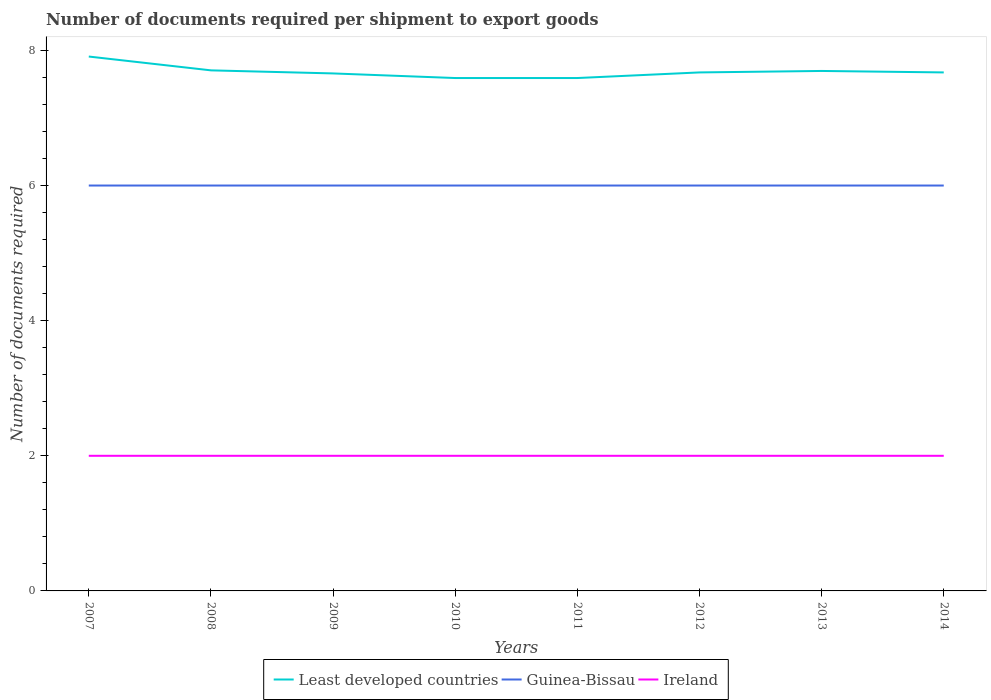How many different coloured lines are there?
Make the answer very short. 3. Does the line corresponding to Least developed countries intersect with the line corresponding to Ireland?
Ensure brevity in your answer.  No. Across all years, what is the maximum number of documents required per shipment to export goods in Least developed countries?
Provide a short and direct response. 7.59. What is the total number of documents required per shipment to export goods in Least developed countries in the graph?
Provide a succinct answer. 0.32. What is the difference between the highest and the lowest number of documents required per shipment to export goods in Least developed countries?
Provide a succinct answer. 3. How many years are there in the graph?
Offer a very short reply. 8. What is the difference between two consecutive major ticks on the Y-axis?
Your answer should be compact. 2. Where does the legend appear in the graph?
Your answer should be very brief. Bottom center. How many legend labels are there?
Provide a succinct answer. 3. How are the legend labels stacked?
Keep it short and to the point. Horizontal. What is the title of the graph?
Make the answer very short. Number of documents required per shipment to export goods. Does "Latin America(developing only)" appear as one of the legend labels in the graph?
Ensure brevity in your answer.  No. What is the label or title of the Y-axis?
Provide a short and direct response. Number of documents required. What is the Number of documents required of Least developed countries in 2007?
Offer a very short reply. 7.91. What is the Number of documents required of Guinea-Bissau in 2007?
Keep it short and to the point. 6. What is the Number of documents required of Least developed countries in 2008?
Your response must be concise. 7.7. What is the Number of documents required of Least developed countries in 2009?
Offer a terse response. 7.66. What is the Number of documents required of Guinea-Bissau in 2009?
Provide a short and direct response. 6. What is the Number of documents required in Least developed countries in 2010?
Make the answer very short. 7.59. What is the Number of documents required in Least developed countries in 2011?
Offer a very short reply. 7.59. What is the Number of documents required of Guinea-Bissau in 2011?
Give a very brief answer. 6. What is the Number of documents required of Ireland in 2011?
Provide a succinct answer. 2. What is the Number of documents required of Least developed countries in 2012?
Make the answer very short. 7.67. What is the Number of documents required in Ireland in 2012?
Provide a short and direct response. 2. What is the Number of documents required in Least developed countries in 2013?
Provide a succinct answer. 7.7. What is the Number of documents required of Ireland in 2013?
Give a very brief answer. 2. What is the Number of documents required of Least developed countries in 2014?
Ensure brevity in your answer.  7.67. Across all years, what is the maximum Number of documents required in Least developed countries?
Offer a very short reply. 7.91. Across all years, what is the maximum Number of documents required of Ireland?
Your response must be concise. 2. Across all years, what is the minimum Number of documents required in Least developed countries?
Make the answer very short. 7.59. Across all years, what is the minimum Number of documents required in Guinea-Bissau?
Offer a very short reply. 6. What is the total Number of documents required of Least developed countries in the graph?
Provide a succinct answer. 61.5. What is the difference between the Number of documents required of Least developed countries in 2007 and that in 2008?
Provide a succinct answer. 0.2. What is the difference between the Number of documents required of Guinea-Bissau in 2007 and that in 2008?
Your answer should be very brief. 0. What is the difference between the Number of documents required in Least developed countries in 2007 and that in 2009?
Offer a very short reply. 0.25. What is the difference between the Number of documents required of Guinea-Bissau in 2007 and that in 2009?
Make the answer very short. 0. What is the difference between the Number of documents required in Ireland in 2007 and that in 2009?
Make the answer very short. 0. What is the difference between the Number of documents required in Least developed countries in 2007 and that in 2010?
Provide a succinct answer. 0.32. What is the difference between the Number of documents required of Guinea-Bissau in 2007 and that in 2010?
Provide a succinct answer. 0. What is the difference between the Number of documents required of Least developed countries in 2007 and that in 2011?
Ensure brevity in your answer.  0.32. What is the difference between the Number of documents required of Guinea-Bissau in 2007 and that in 2011?
Your answer should be very brief. 0. What is the difference between the Number of documents required of Ireland in 2007 and that in 2011?
Provide a succinct answer. 0. What is the difference between the Number of documents required in Least developed countries in 2007 and that in 2012?
Your answer should be compact. 0.24. What is the difference between the Number of documents required of Guinea-Bissau in 2007 and that in 2012?
Keep it short and to the point. 0. What is the difference between the Number of documents required of Ireland in 2007 and that in 2012?
Offer a very short reply. 0. What is the difference between the Number of documents required of Least developed countries in 2007 and that in 2013?
Give a very brief answer. 0.21. What is the difference between the Number of documents required in Ireland in 2007 and that in 2013?
Your answer should be compact. 0. What is the difference between the Number of documents required of Least developed countries in 2007 and that in 2014?
Your answer should be compact. 0.24. What is the difference between the Number of documents required of Ireland in 2007 and that in 2014?
Your answer should be very brief. 0. What is the difference between the Number of documents required of Least developed countries in 2008 and that in 2009?
Ensure brevity in your answer.  0.05. What is the difference between the Number of documents required in Guinea-Bissau in 2008 and that in 2009?
Keep it short and to the point. 0. What is the difference between the Number of documents required of Least developed countries in 2008 and that in 2010?
Provide a short and direct response. 0.11. What is the difference between the Number of documents required of Guinea-Bissau in 2008 and that in 2010?
Keep it short and to the point. 0. What is the difference between the Number of documents required in Least developed countries in 2008 and that in 2011?
Give a very brief answer. 0.11. What is the difference between the Number of documents required of Ireland in 2008 and that in 2011?
Your answer should be very brief. 0. What is the difference between the Number of documents required in Least developed countries in 2008 and that in 2012?
Your answer should be compact. 0.03. What is the difference between the Number of documents required in Guinea-Bissau in 2008 and that in 2012?
Your response must be concise. 0. What is the difference between the Number of documents required in Least developed countries in 2008 and that in 2013?
Keep it short and to the point. 0.01. What is the difference between the Number of documents required in Least developed countries in 2008 and that in 2014?
Your answer should be compact. 0.03. What is the difference between the Number of documents required of Guinea-Bissau in 2008 and that in 2014?
Make the answer very short. 0. What is the difference between the Number of documents required in Least developed countries in 2009 and that in 2010?
Give a very brief answer. 0.07. What is the difference between the Number of documents required of Least developed countries in 2009 and that in 2011?
Offer a terse response. 0.07. What is the difference between the Number of documents required of Guinea-Bissau in 2009 and that in 2011?
Your response must be concise. 0. What is the difference between the Number of documents required in Least developed countries in 2009 and that in 2012?
Your response must be concise. -0.01. What is the difference between the Number of documents required of Guinea-Bissau in 2009 and that in 2012?
Keep it short and to the point. 0. What is the difference between the Number of documents required of Least developed countries in 2009 and that in 2013?
Your answer should be compact. -0.04. What is the difference between the Number of documents required in Ireland in 2009 and that in 2013?
Provide a succinct answer. 0. What is the difference between the Number of documents required in Least developed countries in 2009 and that in 2014?
Make the answer very short. -0.01. What is the difference between the Number of documents required in Least developed countries in 2010 and that in 2011?
Offer a very short reply. 0. What is the difference between the Number of documents required of Ireland in 2010 and that in 2011?
Offer a terse response. 0. What is the difference between the Number of documents required of Least developed countries in 2010 and that in 2012?
Keep it short and to the point. -0.08. What is the difference between the Number of documents required of Least developed countries in 2010 and that in 2013?
Provide a short and direct response. -0.1. What is the difference between the Number of documents required of Guinea-Bissau in 2010 and that in 2013?
Give a very brief answer. 0. What is the difference between the Number of documents required of Least developed countries in 2010 and that in 2014?
Offer a very short reply. -0.08. What is the difference between the Number of documents required of Least developed countries in 2011 and that in 2012?
Ensure brevity in your answer.  -0.08. What is the difference between the Number of documents required of Ireland in 2011 and that in 2012?
Your answer should be compact. 0. What is the difference between the Number of documents required in Least developed countries in 2011 and that in 2013?
Make the answer very short. -0.1. What is the difference between the Number of documents required of Ireland in 2011 and that in 2013?
Offer a very short reply. 0. What is the difference between the Number of documents required in Least developed countries in 2011 and that in 2014?
Offer a terse response. -0.08. What is the difference between the Number of documents required in Ireland in 2011 and that in 2014?
Your answer should be very brief. 0. What is the difference between the Number of documents required of Least developed countries in 2012 and that in 2013?
Provide a succinct answer. -0.02. What is the difference between the Number of documents required of Guinea-Bissau in 2012 and that in 2013?
Keep it short and to the point. 0. What is the difference between the Number of documents required of Least developed countries in 2012 and that in 2014?
Give a very brief answer. 0. What is the difference between the Number of documents required in Guinea-Bissau in 2012 and that in 2014?
Give a very brief answer. 0. What is the difference between the Number of documents required in Least developed countries in 2013 and that in 2014?
Your answer should be compact. 0.02. What is the difference between the Number of documents required of Least developed countries in 2007 and the Number of documents required of Guinea-Bissau in 2008?
Give a very brief answer. 1.91. What is the difference between the Number of documents required in Least developed countries in 2007 and the Number of documents required in Ireland in 2008?
Your answer should be very brief. 5.91. What is the difference between the Number of documents required in Guinea-Bissau in 2007 and the Number of documents required in Ireland in 2008?
Provide a short and direct response. 4. What is the difference between the Number of documents required in Least developed countries in 2007 and the Number of documents required in Guinea-Bissau in 2009?
Keep it short and to the point. 1.91. What is the difference between the Number of documents required of Least developed countries in 2007 and the Number of documents required of Ireland in 2009?
Your answer should be very brief. 5.91. What is the difference between the Number of documents required of Guinea-Bissau in 2007 and the Number of documents required of Ireland in 2009?
Your answer should be very brief. 4. What is the difference between the Number of documents required of Least developed countries in 2007 and the Number of documents required of Guinea-Bissau in 2010?
Offer a terse response. 1.91. What is the difference between the Number of documents required in Least developed countries in 2007 and the Number of documents required in Ireland in 2010?
Provide a succinct answer. 5.91. What is the difference between the Number of documents required of Guinea-Bissau in 2007 and the Number of documents required of Ireland in 2010?
Your answer should be very brief. 4. What is the difference between the Number of documents required in Least developed countries in 2007 and the Number of documents required in Guinea-Bissau in 2011?
Provide a short and direct response. 1.91. What is the difference between the Number of documents required of Least developed countries in 2007 and the Number of documents required of Ireland in 2011?
Offer a terse response. 5.91. What is the difference between the Number of documents required of Least developed countries in 2007 and the Number of documents required of Guinea-Bissau in 2012?
Offer a very short reply. 1.91. What is the difference between the Number of documents required of Least developed countries in 2007 and the Number of documents required of Ireland in 2012?
Your response must be concise. 5.91. What is the difference between the Number of documents required of Least developed countries in 2007 and the Number of documents required of Guinea-Bissau in 2013?
Your response must be concise. 1.91. What is the difference between the Number of documents required of Least developed countries in 2007 and the Number of documents required of Ireland in 2013?
Provide a succinct answer. 5.91. What is the difference between the Number of documents required of Least developed countries in 2007 and the Number of documents required of Guinea-Bissau in 2014?
Offer a terse response. 1.91. What is the difference between the Number of documents required in Least developed countries in 2007 and the Number of documents required in Ireland in 2014?
Offer a very short reply. 5.91. What is the difference between the Number of documents required of Least developed countries in 2008 and the Number of documents required of Guinea-Bissau in 2009?
Provide a succinct answer. 1.7. What is the difference between the Number of documents required in Least developed countries in 2008 and the Number of documents required in Ireland in 2009?
Provide a short and direct response. 5.7. What is the difference between the Number of documents required of Guinea-Bissau in 2008 and the Number of documents required of Ireland in 2009?
Keep it short and to the point. 4. What is the difference between the Number of documents required in Least developed countries in 2008 and the Number of documents required in Guinea-Bissau in 2010?
Ensure brevity in your answer.  1.7. What is the difference between the Number of documents required of Least developed countries in 2008 and the Number of documents required of Ireland in 2010?
Give a very brief answer. 5.7. What is the difference between the Number of documents required in Least developed countries in 2008 and the Number of documents required in Guinea-Bissau in 2011?
Make the answer very short. 1.7. What is the difference between the Number of documents required of Least developed countries in 2008 and the Number of documents required of Ireland in 2011?
Offer a terse response. 5.7. What is the difference between the Number of documents required in Guinea-Bissau in 2008 and the Number of documents required in Ireland in 2011?
Make the answer very short. 4. What is the difference between the Number of documents required of Least developed countries in 2008 and the Number of documents required of Guinea-Bissau in 2012?
Your answer should be very brief. 1.7. What is the difference between the Number of documents required in Least developed countries in 2008 and the Number of documents required in Ireland in 2012?
Provide a short and direct response. 5.7. What is the difference between the Number of documents required of Guinea-Bissau in 2008 and the Number of documents required of Ireland in 2012?
Give a very brief answer. 4. What is the difference between the Number of documents required of Least developed countries in 2008 and the Number of documents required of Guinea-Bissau in 2013?
Provide a succinct answer. 1.7. What is the difference between the Number of documents required of Least developed countries in 2008 and the Number of documents required of Ireland in 2013?
Make the answer very short. 5.7. What is the difference between the Number of documents required in Least developed countries in 2008 and the Number of documents required in Guinea-Bissau in 2014?
Provide a succinct answer. 1.7. What is the difference between the Number of documents required in Least developed countries in 2008 and the Number of documents required in Ireland in 2014?
Keep it short and to the point. 5.7. What is the difference between the Number of documents required of Guinea-Bissau in 2008 and the Number of documents required of Ireland in 2014?
Offer a very short reply. 4. What is the difference between the Number of documents required of Least developed countries in 2009 and the Number of documents required of Guinea-Bissau in 2010?
Offer a terse response. 1.66. What is the difference between the Number of documents required of Least developed countries in 2009 and the Number of documents required of Ireland in 2010?
Make the answer very short. 5.66. What is the difference between the Number of documents required in Least developed countries in 2009 and the Number of documents required in Guinea-Bissau in 2011?
Offer a terse response. 1.66. What is the difference between the Number of documents required of Least developed countries in 2009 and the Number of documents required of Ireland in 2011?
Your answer should be compact. 5.66. What is the difference between the Number of documents required in Least developed countries in 2009 and the Number of documents required in Guinea-Bissau in 2012?
Make the answer very short. 1.66. What is the difference between the Number of documents required of Least developed countries in 2009 and the Number of documents required of Ireland in 2012?
Ensure brevity in your answer.  5.66. What is the difference between the Number of documents required of Least developed countries in 2009 and the Number of documents required of Guinea-Bissau in 2013?
Offer a very short reply. 1.66. What is the difference between the Number of documents required of Least developed countries in 2009 and the Number of documents required of Ireland in 2013?
Provide a short and direct response. 5.66. What is the difference between the Number of documents required of Guinea-Bissau in 2009 and the Number of documents required of Ireland in 2013?
Provide a succinct answer. 4. What is the difference between the Number of documents required of Least developed countries in 2009 and the Number of documents required of Guinea-Bissau in 2014?
Offer a terse response. 1.66. What is the difference between the Number of documents required of Least developed countries in 2009 and the Number of documents required of Ireland in 2014?
Your answer should be compact. 5.66. What is the difference between the Number of documents required in Guinea-Bissau in 2009 and the Number of documents required in Ireland in 2014?
Offer a terse response. 4. What is the difference between the Number of documents required in Least developed countries in 2010 and the Number of documents required in Guinea-Bissau in 2011?
Your answer should be compact. 1.59. What is the difference between the Number of documents required of Least developed countries in 2010 and the Number of documents required of Ireland in 2011?
Your answer should be very brief. 5.59. What is the difference between the Number of documents required in Least developed countries in 2010 and the Number of documents required in Guinea-Bissau in 2012?
Offer a terse response. 1.59. What is the difference between the Number of documents required in Least developed countries in 2010 and the Number of documents required in Ireland in 2012?
Your answer should be very brief. 5.59. What is the difference between the Number of documents required in Least developed countries in 2010 and the Number of documents required in Guinea-Bissau in 2013?
Your answer should be very brief. 1.59. What is the difference between the Number of documents required in Least developed countries in 2010 and the Number of documents required in Ireland in 2013?
Your response must be concise. 5.59. What is the difference between the Number of documents required of Guinea-Bissau in 2010 and the Number of documents required of Ireland in 2013?
Offer a terse response. 4. What is the difference between the Number of documents required in Least developed countries in 2010 and the Number of documents required in Guinea-Bissau in 2014?
Offer a terse response. 1.59. What is the difference between the Number of documents required of Least developed countries in 2010 and the Number of documents required of Ireland in 2014?
Provide a succinct answer. 5.59. What is the difference between the Number of documents required of Guinea-Bissau in 2010 and the Number of documents required of Ireland in 2014?
Your answer should be very brief. 4. What is the difference between the Number of documents required of Least developed countries in 2011 and the Number of documents required of Guinea-Bissau in 2012?
Your answer should be compact. 1.59. What is the difference between the Number of documents required of Least developed countries in 2011 and the Number of documents required of Ireland in 2012?
Provide a succinct answer. 5.59. What is the difference between the Number of documents required in Least developed countries in 2011 and the Number of documents required in Guinea-Bissau in 2013?
Make the answer very short. 1.59. What is the difference between the Number of documents required in Least developed countries in 2011 and the Number of documents required in Ireland in 2013?
Keep it short and to the point. 5.59. What is the difference between the Number of documents required of Guinea-Bissau in 2011 and the Number of documents required of Ireland in 2013?
Provide a succinct answer. 4. What is the difference between the Number of documents required in Least developed countries in 2011 and the Number of documents required in Guinea-Bissau in 2014?
Ensure brevity in your answer.  1.59. What is the difference between the Number of documents required of Least developed countries in 2011 and the Number of documents required of Ireland in 2014?
Ensure brevity in your answer.  5.59. What is the difference between the Number of documents required in Guinea-Bissau in 2011 and the Number of documents required in Ireland in 2014?
Ensure brevity in your answer.  4. What is the difference between the Number of documents required in Least developed countries in 2012 and the Number of documents required in Guinea-Bissau in 2013?
Keep it short and to the point. 1.67. What is the difference between the Number of documents required in Least developed countries in 2012 and the Number of documents required in Ireland in 2013?
Offer a terse response. 5.67. What is the difference between the Number of documents required of Least developed countries in 2012 and the Number of documents required of Guinea-Bissau in 2014?
Provide a succinct answer. 1.67. What is the difference between the Number of documents required of Least developed countries in 2012 and the Number of documents required of Ireland in 2014?
Your answer should be compact. 5.67. What is the difference between the Number of documents required of Least developed countries in 2013 and the Number of documents required of Guinea-Bissau in 2014?
Your response must be concise. 1.7. What is the difference between the Number of documents required of Least developed countries in 2013 and the Number of documents required of Ireland in 2014?
Make the answer very short. 5.7. What is the difference between the Number of documents required of Guinea-Bissau in 2013 and the Number of documents required of Ireland in 2014?
Make the answer very short. 4. What is the average Number of documents required of Least developed countries per year?
Provide a short and direct response. 7.69. What is the average Number of documents required of Guinea-Bissau per year?
Ensure brevity in your answer.  6. In the year 2007, what is the difference between the Number of documents required in Least developed countries and Number of documents required in Guinea-Bissau?
Offer a terse response. 1.91. In the year 2007, what is the difference between the Number of documents required of Least developed countries and Number of documents required of Ireland?
Provide a succinct answer. 5.91. In the year 2007, what is the difference between the Number of documents required of Guinea-Bissau and Number of documents required of Ireland?
Your response must be concise. 4. In the year 2008, what is the difference between the Number of documents required of Least developed countries and Number of documents required of Guinea-Bissau?
Your answer should be compact. 1.7. In the year 2008, what is the difference between the Number of documents required of Least developed countries and Number of documents required of Ireland?
Keep it short and to the point. 5.7. In the year 2009, what is the difference between the Number of documents required of Least developed countries and Number of documents required of Guinea-Bissau?
Provide a short and direct response. 1.66. In the year 2009, what is the difference between the Number of documents required in Least developed countries and Number of documents required in Ireland?
Provide a short and direct response. 5.66. In the year 2010, what is the difference between the Number of documents required in Least developed countries and Number of documents required in Guinea-Bissau?
Offer a terse response. 1.59. In the year 2010, what is the difference between the Number of documents required of Least developed countries and Number of documents required of Ireland?
Provide a short and direct response. 5.59. In the year 2011, what is the difference between the Number of documents required in Least developed countries and Number of documents required in Guinea-Bissau?
Keep it short and to the point. 1.59. In the year 2011, what is the difference between the Number of documents required of Least developed countries and Number of documents required of Ireland?
Make the answer very short. 5.59. In the year 2011, what is the difference between the Number of documents required in Guinea-Bissau and Number of documents required in Ireland?
Offer a very short reply. 4. In the year 2012, what is the difference between the Number of documents required in Least developed countries and Number of documents required in Guinea-Bissau?
Give a very brief answer. 1.67. In the year 2012, what is the difference between the Number of documents required of Least developed countries and Number of documents required of Ireland?
Ensure brevity in your answer.  5.67. In the year 2013, what is the difference between the Number of documents required in Least developed countries and Number of documents required in Guinea-Bissau?
Ensure brevity in your answer.  1.7. In the year 2013, what is the difference between the Number of documents required in Least developed countries and Number of documents required in Ireland?
Offer a terse response. 5.7. In the year 2013, what is the difference between the Number of documents required of Guinea-Bissau and Number of documents required of Ireland?
Your response must be concise. 4. In the year 2014, what is the difference between the Number of documents required in Least developed countries and Number of documents required in Guinea-Bissau?
Offer a terse response. 1.67. In the year 2014, what is the difference between the Number of documents required in Least developed countries and Number of documents required in Ireland?
Offer a terse response. 5.67. In the year 2014, what is the difference between the Number of documents required in Guinea-Bissau and Number of documents required in Ireland?
Your answer should be very brief. 4. What is the ratio of the Number of documents required in Least developed countries in 2007 to that in 2008?
Provide a succinct answer. 1.03. What is the ratio of the Number of documents required of Least developed countries in 2007 to that in 2009?
Keep it short and to the point. 1.03. What is the ratio of the Number of documents required of Guinea-Bissau in 2007 to that in 2009?
Ensure brevity in your answer.  1. What is the ratio of the Number of documents required of Ireland in 2007 to that in 2009?
Offer a terse response. 1. What is the ratio of the Number of documents required in Least developed countries in 2007 to that in 2010?
Your answer should be compact. 1.04. What is the ratio of the Number of documents required in Ireland in 2007 to that in 2010?
Offer a very short reply. 1. What is the ratio of the Number of documents required of Least developed countries in 2007 to that in 2011?
Your answer should be very brief. 1.04. What is the ratio of the Number of documents required in Least developed countries in 2007 to that in 2012?
Offer a terse response. 1.03. What is the ratio of the Number of documents required in Ireland in 2007 to that in 2012?
Your response must be concise. 1. What is the ratio of the Number of documents required in Least developed countries in 2007 to that in 2013?
Ensure brevity in your answer.  1.03. What is the ratio of the Number of documents required of Least developed countries in 2007 to that in 2014?
Your answer should be very brief. 1.03. What is the ratio of the Number of documents required of Guinea-Bissau in 2007 to that in 2014?
Your response must be concise. 1. What is the ratio of the Number of documents required of Least developed countries in 2008 to that in 2009?
Provide a succinct answer. 1.01. What is the ratio of the Number of documents required of Least developed countries in 2008 to that in 2010?
Offer a terse response. 1.01. What is the ratio of the Number of documents required of Ireland in 2008 to that in 2010?
Make the answer very short. 1. What is the ratio of the Number of documents required in Least developed countries in 2008 to that in 2011?
Keep it short and to the point. 1.01. What is the ratio of the Number of documents required of Ireland in 2008 to that in 2011?
Give a very brief answer. 1. What is the ratio of the Number of documents required in Guinea-Bissau in 2008 to that in 2013?
Ensure brevity in your answer.  1. What is the ratio of the Number of documents required in Least developed countries in 2008 to that in 2014?
Provide a succinct answer. 1. What is the ratio of the Number of documents required in Ireland in 2008 to that in 2014?
Your response must be concise. 1. What is the ratio of the Number of documents required in Least developed countries in 2009 to that in 2012?
Keep it short and to the point. 1. What is the ratio of the Number of documents required in Guinea-Bissau in 2009 to that in 2012?
Provide a succinct answer. 1. What is the ratio of the Number of documents required in Ireland in 2009 to that in 2012?
Your answer should be compact. 1. What is the ratio of the Number of documents required of Guinea-Bissau in 2009 to that in 2013?
Provide a succinct answer. 1. What is the ratio of the Number of documents required in Ireland in 2009 to that in 2013?
Give a very brief answer. 1. What is the ratio of the Number of documents required of Least developed countries in 2009 to that in 2014?
Your response must be concise. 1. What is the ratio of the Number of documents required in Guinea-Bissau in 2010 to that in 2011?
Offer a terse response. 1. What is the ratio of the Number of documents required in Ireland in 2010 to that in 2011?
Provide a succinct answer. 1. What is the ratio of the Number of documents required of Least developed countries in 2010 to that in 2012?
Keep it short and to the point. 0.99. What is the ratio of the Number of documents required in Ireland in 2010 to that in 2012?
Offer a terse response. 1. What is the ratio of the Number of documents required in Least developed countries in 2010 to that in 2013?
Your answer should be very brief. 0.99. What is the ratio of the Number of documents required of Ireland in 2010 to that in 2013?
Keep it short and to the point. 1. What is the ratio of the Number of documents required of Least developed countries in 2010 to that in 2014?
Your answer should be compact. 0.99. What is the ratio of the Number of documents required of Guinea-Bissau in 2010 to that in 2014?
Offer a terse response. 1. What is the ratio of the Number of documents required in Least developed countries in 2011 to that in 2012?
Your answer should be compact. 0.99. What is the ratio of the Number of documents required in Guinea-Bissau in 2011 to that in 2012?
Provide a succinct answer. 1. What is the ratio of the Number of documents required of Least developed countries in 2011 to that in 2013?
Keep it short and to the point. 0.99. What is the ratio of the Number of documents required of Ireland in 2011 to that in 2013?
Offer a terse response. 1. What is the ratio of the Number of documents required in Least developed countries in 2011 to that in 2014?
Offer a terse response. 0.99. What is the ratio of the Number of documents required in Guinea-Bissau in 2012 to that in 2013?
Make the answer very short. 1. What is the ratio of the Number of documents required of Least developed countries in 2012 to that in 2014?
Make the answer very short. 1. What is the ratio of the Number of documents required of Ireland in 2012 to that in 2014?
Keep it short and to the point. 1. What is the ratio of the Number of documents required in Guinea-Bissau in 2013 to that in 2014?
Make the answer very short. 1. What is the difference between the highest and the second highest Number of documents required of Least developed countries?
Offer a very short reply. 0.2. What is the difference between the highest and the second highest Number of documents required in Guinea-Bissau?
Your response must be concise. 0. What is the difference between the highest and the second highest Number of documents required of Ireland?
Offer a terse response. 0. What is the difference between the highest and the lowest Number of documents required in Least developed countries?
Make the answer very short. 0.32. 